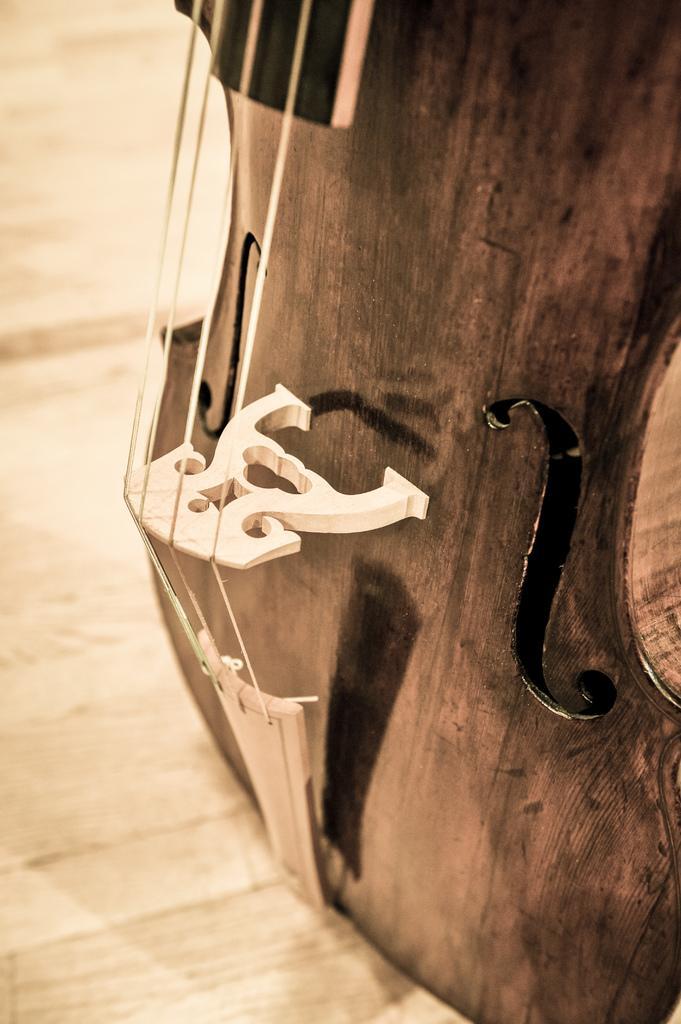How would you summarize this image in a sentence or two? In the picture we can see a part of the guitar with strings which is placed on the wooden surface. 